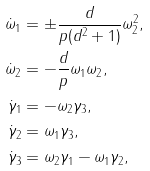Convert formula to latex. <formula><loc_0><loc_0><loc_500><loc_500>\dot { \omega } _ { 1 } & = \pm \frac { d } { p ( d ^ { 2 } + 1 ) } \omega _ { 2 } ^ { 2 } , \\ \dot { \omega } _ { 2 } & = - \frac { d } { p } \omega _ { 1 } \omega _ { 2 } , \\ \dot { \gamma } _ { 1 } & = - \omega _ { 2 } \gamma _ { 3 } , \\ \dot { \gamma } _ { 2 } & = \omega _ { 1 } \gamma _ { 3 } , \\ \dot { \gamma } _ { 3 } & = \omega _ { 2 } \gamma _ { 1 } - \omega _ { 1 } \gamma _ { 2 } ,</formula> 